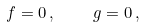<formula> <loc_0><loc_0><loc_500><loc_500>f = 0 \, , \quad g = 0 \, ,</formula> 